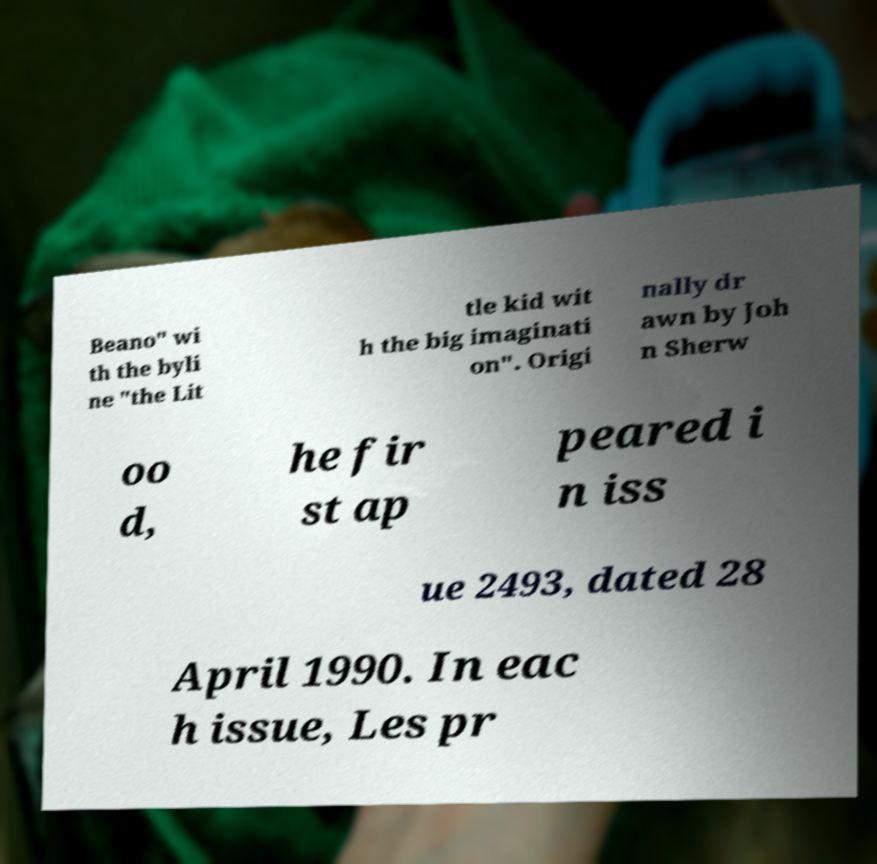Could you assist in decoding the text presented in this image and type it out clearly? Beano" wi th the byli ne "the Lit tle kid wit h the big imaginati on". Origi nally dr awn by Joh n Sherw oo d, he fir st ap peared i n iss ue 2493, dated 28 April 1990. In eac h issue, Les pr 